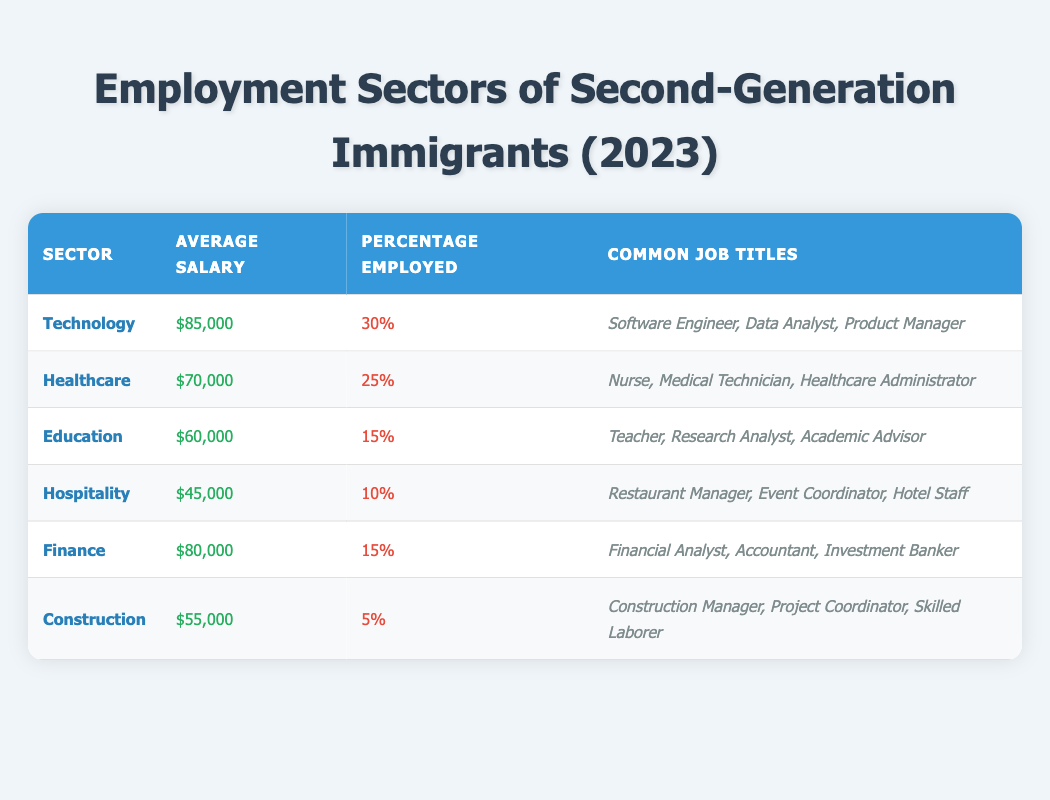What is the average salary for the Technology sector? The Technology sector has an average salary of $85,000 listed in the table.
Answer: $85,000 Which sector has the highest percentage of employment? According to the table, the Technology sector has the highest percentage of employed individuals at 30%.
Answer: Technology Is the average salary in the Healthcare sector higher than in the Hospitality sector? The average salary in Healthcare is $70,000, while in Hospitality it is $45,000. Since $70,000 is greater than $45,000, the statement is true.
Answer: Yes How many sectors have an average salary of $60,000 or less? From the table, the sectors with an average salary of $60,000 or less are Education ($60,000), Hospitality ($45,000), and Construction ($55,000), totaling three sectors.
Answer: 3 What is the total percentage of employed individuals across all sectors listed? The total percentage of employed individuals is calculated by adding the percentages from each sector: 30% (Technology) + 25% (Healthcare) + 15% (Education) + 10% (Hospitality) + 15% (Finance) + 5% (Construction) = 100%.
Answer: 100% Are nurses among the common job titles listed for the Finance sector? According to the table, the common job titles in the Finance sector are Financial Analyst, Accountant, and Investment Banker. Since nurses are not mentioned, the statement is false.
Answer: No Which sector has the least percentage of employment, and what is that percentage? The sector with the least percentage of employment is Construction, which has a percentage of 5% as shown in the table.
Answer: Construction, 5% If you combine the average salaries of the Technology and Finance sectors, what would be the total? The average salary for Technology is $85,000, and for Finance is $80,000. Adding them gives $85,000 + $80,000 = $165,000.
Answer: $165,000 